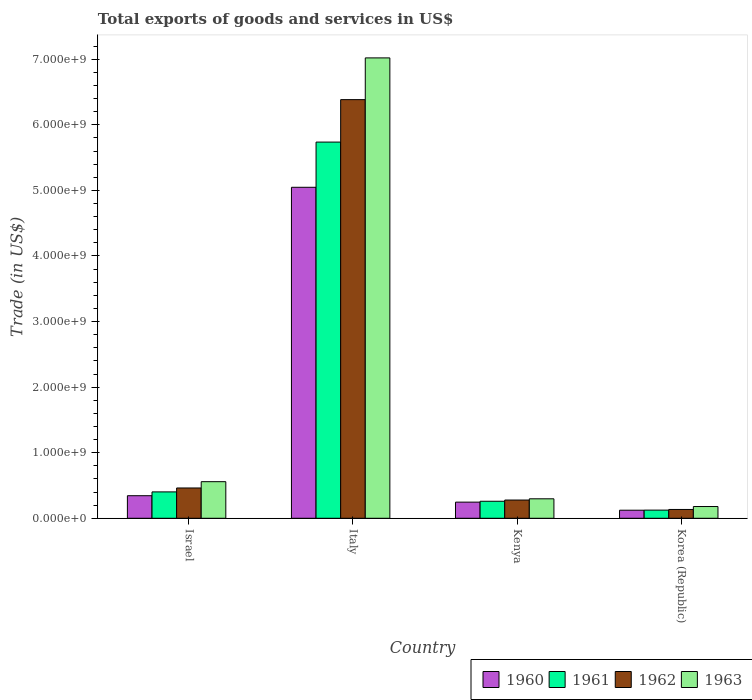Are the number of bars on each tick of the X-axis equal?
Your response must be concise. Yes. In how many cases, is the number of bars for a given country not equal to the number of legend labels?
Make the answer very short. 0. What is the total exports of goods and services in 1960 in Kenya?
Keep it short and to the point. 2.46e+08. Across all countries, what is the maximum total exports of goods and services in 1960?
Make the answer very short. 5.05e+09. Across all countries, what is the minimum total exports of goods and services in 1960?
Make the answer very short. 1.23e+08. In which country was the total exports of goods and services in 1960 maximum?
Offer a very short reply. Italy. What is the total total exports of goods and services in 1960 in the graph?
Offer a very short reply. 5.76e+09. What is the difference between the total exports of goods and services in 1960 in Israel and that in Korea (Republic)?
Your answer should be very brief. 2.21e+08. What is the difference between the total exports of goods and services in 1960 in Italy and the total exports of goods and services in 1962 in Korea (Republic)?
Offer a terse response. 4.91e+09. What is the average total exports of goods and services in 1962 per country?
Give a very brief answer. 1.81e+09. What is the difference between the total exports of goods and services of/in 1960 and total exports of goods and services of/in 1963 in Israel?
Give a very brief answer. -2.14e+08. In how many countries, is the total exports of goods and services in 1960 greater than 2400000000 US$?
Keep it short and to the point. 1. What is the ratio of the total exports of goods and services in 1962 in Israel to that in Kenya?
Your response must be concise. 1.66. Is the total exports of goods and services in 1961 in Italy less than that in Korea (Republic)?
Give a very brief answer. No. What is the difference between the highest and the second highest total exports of goods and services in 1961?
Ensure brevity in your answer.  1.43e+08. What is the difference between the highest and the lowest total exports of goods and services in 1961?
Keep it short and to the point. 5.61e+09. In how many countries, is the total exports of goods and services in 1963 greater than the average total exports of goods and services in 1963 taken over all countries?
Provide a short and direct response. 1. Is it the case that in every country, the sum of the total exports of goods and services in 1963 and total exports of goods and services in 1962 is greater than the sum of total exports of goods and services in 1960 and total exports of goods and services in 1961?
Keep it short and to the point. No. What does the 4th bar from the left in Korea (Republic) represents?
Your answer should be very brief. 1963. How many bars are there?
Your answer should be compact. 16. Are all the bars in the graph horizontal?
Offer a terse response. No. What is the difference between two consecutive major ticks on the Y-axis?
Ensure brevity in your answer.  1.00e+09. Does the graph contain any zero values?
Offer a very short reply. No. Does the graph contain grids?
Your answer should be very brief. No. How many legend labels are there?
Offer a very short reply. 4. What is the title of the graph?
Make the answer very short. Total exports of goods and services in US$. What is the label or title of the Y-axis?
Offer a terse response. Trade (in US$). What is the Trade (in US$) of 1960 in Israel?
Provide a succinct answer. 3.44e+08. What is the Trade (in US$) in 1961 in Israel?
Keep it short and to the point. 4.02e+08. What is the Trade (in US$) in 1962 in Israel?
Keep it short and to the point. 4.62e+08. What is the Trade (in US$) in 1963 in Israel?
Give a very brief answer. 5.58e+08. What is the Trade (in US$) of 1960 in Italy?
Provide a succinct answer. 5.05e+09. What is the Trade (in US$) of 1961 in Italy?
Provide a short and direct response. 5.74e+09. What is the Trade (in US$) of 1962 in Italy?
Ensure brevity in your answer.  6.38e+09. What is the Trade (in US$) of 1963 in Italy?
Offer a very short reply. 7.02e+09. What is the Trade (in US$) in 1960 in Kenya?
Make the answer very short. 2.46e+08. What is the Trade (in US$) in 1961 in Kenya?
Your answer should be compact. 2.59e+08. What is the Trade (in US$) in 1962 in Kenya?
Your answer should be compact. 2.78e+08. What is the Trade (in US$) in 1963 in Kenya?
Offer a terse response. 2.97e+08. What is the Trade (in US$) of 1960 in Korea (Republic)?
Make the answer very short. 1.23e+08. What is the Trade (in US$) of 1961 in Korea (Republic)?
Your answer should be compact. 1.24e+08. What is the Trade (in US$) in 1962 in Korea (Republic)?
Offer a terse response. 1.34e+08. What is the Trade (in US$) of 1963 in Korea (Republic)?
Your answer should be compact. 1.79e+08. Across all countries, what is the maximum Trade (in US$) of 1960?
Keep it short and to the point. 5.05e+09. Across all countries, what is the maximum Trade (in US$) of 1961?
Offer a very short reply. 5.74e+09. Across all countries, what is the maximum Trade (in US$) in 1962?
Offer a terse response. 6.38e+09. Across all countries, what is the maximum Trade (in US$) in 1963?
Your answer should be compact. 7.02e+09. Across all countries, what is the minimum Trade (in US$) of 1960?
Make the answer very short. 1.23e+08. Across all countries, what is the minimum Trade (in US$) of 1961?
Your answer should be compact. 1.24e+08. Across all countries, what is the minimum Trade (in US$) of 1962?
Offer a terse response. 1.34e+08. Across all countries, what is the minimum Trade (in US$) of 1963?
Your answer should be very brief. 1.79e+08. What is the total Trade (in US$) in 1960 in the graph?
Provide a succinct answer. 5.76e+09. What is the total Trade (in US$) in 1961 in the graph?
Keep it short and to the point. 6.52e+09. What is the total Trade (in US$) in 1962 in the graph?
Give a very brief answer. 7.26e+09. What is the total Trade (in US$) in 1963 in the graph?
Offer a very short reply. 8.05e+09. What is the difference between the Trade (in US$) in 1960 in Israel and that in Italy?
Your response must be concise. -4.70e+09. What is the difference between the Trade (in US$) in 1961 in Israel and that in Italy?
Keep it short and to the point. -5.33e+09. What is the difference between the Trade (in US$) in 1962 in Israel and that in Italy?
Offer a very short reply. -5.92e+09. What is the difference between the Trade (in US$) in 1963 in Israel and that in Italy?
Give a very brief answer. -6.46e+09. What is the difference between the Trade (in US$) of 1960 in Israel and that in Kenya?
Your response must be concise. 9.78e+07. What is the difference between the Trade (in US$) in 1961 in Israel and that in Kenya?
Offer a very short reply. 1.43e+08. What is the difference between the Trade (in US$) in 1962 in Israel and that in Kenya?
Your response must be concise. 1.84e+08. What is the difference between the Trade (in US$) in 1963 in Israel and that in Kenya?
Your answer should be compact. 2.61e+08. What is the difference between the Trade (in US$) in 1960 in Israel and that in Korea (Republic)?
Ensure brevity in your answer.  2.21e+08. What is the difference between the Trade (in US$) of 1961 in Israel and that in Korea (Republic)?
Your answer should be compact. 2.78e+08. What is the difference between the Trade (in US$) in 1962 in Israel and that in Korea (Republic)?
Provide a succinct answer. 3.28e+08. What is the difference between the Trade (in US$) of 1963 in Israel and that in Korea (Republic)?
Give a very brief answer. 3.79e+08. What is the difference between the Trade (in US$) in 1960 in Italy and that in Kenya?
Make the answer very short. 4.80e+09. What is the difference between the Trade (in US$) of 1961 in Italy and that in Kenya?
Provide a short and direct response. 5.48e+09. What is the difference between the Trade (in US$) of 1962 in Italy and that in Kenya?
Your answer should be very brief. 6.11e+09. What is the difference between the Trade (in US$) in 1963 in Italy and that in Kenya?
Make the answer very short. 6.72e+09. What is the difference between the Trade (in US$) in 1960 in Italy and that in Korea (Republic)?
Offer a very short reply. 4.92e+09. What is the difference between the Trade (in US$) in 1961 in Italy and that in Korea (Republic)?
Provide a short and direct response. 5.61e+09. What is the difference between the Trade (in US$) of 1962 in Italy and that in Korea (Republic)?
Provide a short and direct response. 6.25e+09. What is the difference between the Trade (in US$) in 1963 in Italy and that in Korea (Republic)?
Offer a terse response. 6.84e+09. What is the difference between the Trade (in US$) of 1960 in Kenya and that in Korea (Republic)?
Your response must be concise. 1.23e+08. What is the difference between the Trade (in US$) of 1961 in Kenya and that in Korea (Republic)?
Give a very brief answer. 1.35e+08. What is the difference between the Trade (in US$) of 1962 in Kenya and that in Korea (Republic)?
Offer a terse response. 1.44e+08. What is the difference between the Trade (in US$) of 1963 in Kenya and that in Korea (Republic)?
Offer a very short reply. 1.18e+08. What is the difference between the Trade (in US$) in 1960 in Israel and the Trade (in US$) in 1961 in Italy?
Your answer should be very brief. -5.39e+09. What is the difference between the Trade (in US$) of 1960 in Israel and the Trade (in US$) of 1962 in Italy?
Give a very brief answer. -6.04e+09. What is the difference between the Trade (in US$) of 1960 in Israel and the Trade (in US$) of 1963 in Italy?
Provide a succinct answer. -6.68e+09. What is the difference between the Trade (in US$) of 1961 in Israel and the Trade (in US$) of 1962 in Italy?
Your answer should be compact. -5.98e+09. What is the difference between the Trade (in US$) of 1961 in Israel and the Trade (in US$) of 1963 in Italy?
Your answer should be compact. -6.62e+09. What is the difference between the Trade (in US$) in 1962 in Israel and the Trade (in US$) in 1963 in Italy?
Offer a very short reply. -6.56e+09. What is the difference between the Trade (in US$) in 1960 in Israel and the Trade (in US$) in 1961 in Kenya?
Give a very brief answer. 8.45e+07. What is the difference between the Trade (in US$) in 1960 in Israel and the Trade (in US$) in 1962 in Kenya?
Your answer should be compact. 6.58e+07. What is the difference between the Trade (in US$) of 1960 in Israel and the Trade (in US$) of 1963 in Kenya?
Your answer should be very brief. 4.71e+07. What is the difference between the Trade (in US$) of 1961 in Israel and the Trade (in US$) of 1962 in Kenya?
Give a very brief answer. 1.24e+08. What is the difference between the Trade (in US$) in 1961 in Israel and the Trade (in US$) in 1963 in Kenya?
Provide a succinct answer. 1.05e+08. What is the difference between the Trade (in US$) of 1962 in Israel and the Trade (in US$) of 1963 in Kenya?
Your response must be concise. 1.65e+08. What is the difference between the Trade (in US$) in 1960 in Israel and the Trade (in US$) in 1961 in Korea (Republic)?
Provide a succinct answer. 2.20e+08. What is the difference between the Trade (in US$) of 1960 in Israel and the Trade (in US$) of 1962 in Korea (Republic)?
Your answer should be very brief. 2.10e+08. What is the difference between the Trade (in US$) in 1960 in Israel and the Trade (in US$) in 1963 in Korea (Republic)?
Give a very brief answer. 1.65e+08. What is the difference between the Trade (in US$) of 1961 in Israel and the Trade (in US$) of 1962 in Korea (Republic)?
Your answer should be compact. 2.68e+08. What is the difference between the Trade (in US$) of 1961 in Israel and the Trade (in US$) of 1963 in Korea (Republic)?
Give a very brief answer. 2.23e+08. What is the difference between the Trade (in US$) of 1962 in Israel and the Trade (in US$) of 1963 in Korea (Republic)?
Make the answer very short. 2.83e+08. What is the difference between the Trade (in US$) of 1960 in Italy and the Trade (in US$) of 1961 in Kenya?
Provide a succinct answer. 4.79e+09. What is the difference between the Trade (in US$) in 1960 in Italy and the Trade (in US$) in 1962 in Kenya?
Keep it short and to the point. 4.77e+09. What is the difference between the Trade (in US$) in 1960 in Italy and the Trade (in US$) in 1963 in Kenya?
Offer a terse response. 4.75e+09. What is the difference between the Trade (in US$) of 1961 in Italy and the Trade (in US$) of 1962 in Kenya?
Provide a succinct answer. 5.46e+09. What is the difference between the Trade (in US$) in 1961 in Italy and the Trade (in US$) in 1963 in Kenya?
Keep it short and to the point. 5.44e+09. What is the difference between the Trade (in US$) in 1962 in Italy and the Trade (in US$) in 1963 in Kenya?
Your answer should be compact. 6.09e+09. What is the difference between the Trade (in US$) in 1960 in Italy and the Trade (in US$) in 1961 in Korea (Republic)?
Your response must be concise. 4.92e+09. What is the difference between the Trade (in US$) in 1960 in Italy and the Trade (in US$) in 1962 in Korea (Republic)?
Make the answer very short. 4.91e+09. What is the difference between the Trade (in US$) in 1960 in Italy and the Trade (in US$) in 1963 in Korea (Republic)?
Provide a short and direct response. 4.87e+09. What is the difference between the Trade (in US$) of 1961 in Italy and the Trade (in US$) of 1962 in Korea (Republic)?
Your response must be concise. 5.60e+09. What is the difference between the Trade (in US$) of 1961 in Italy and the Trade (in US$) of 1963 in Korea (Republic)?
Make the answer very short. 5.56e+09. What is the difference between the Trade (in US$) of 1962 in Italy and the Trade (in US$) of 1963 in Korea (Republic)?
Keep it short and to the point. 6.20e+09. What is the difference between the Trade (in US$) of 1960 in Kenya and the Trade (in US$) of 1961 in Korea (Republic)?
Give a very brief answer. 1.22e+08. What is the difference between the Trade (in US$) of 1960 in Kenya and the Trade (in US$) of 1962 in Korea (Republic)?
Ensure brevity in your answer.  1.12e+08. What is the difference between the Trade (in US$) in 1960 in Kenya and the Trade (in US$) in 1963 in Korea (Republic)?
Your answer should be very brief. 6.70e+07. What is the difference between the Trade (in US$) in 1961 in Kenya and the Trade (in US$) in 1962 in Korea (Republic)?
Your answer should be very brief. 1.25e+08. What is the difference between the Trade (in US$) of 1961 in Kenya and the Trade (in US$) of 1963 in Korea (Republic)?
Offer a very short reply. 8.04e+07. What is the difference between the Trade (in US$) in 1962 in Kenya and the Trade (in US$) in 1963 in Korea (Republic)?
Your answer should be very brief. 9.91e+07. What is the average Trade (in US$) in 1960 per country?
Offer a terse response. 1.44e+09. What is the average Trade (in US$) in 1961 per country?
Make the answer very short. 1.63e+09. What is the average Trade (in US$) in 1962 per country?
Your response must be concise. 1.81e+09. What is the average Trade (in US$) of 1963 per country?
Your answer should be compact. 2.01e+09. What is the difference between the Trade (in US$) of 1960 and Trade (in US$) of 1961 in Israel?
Your answer should be very brief. -5.83e+07. What is the difference between the Trade (in US$) of 1960 and Trade (in US$) of 1962 in Israel?
Give a very brief answer. -1.18e+08. What is the difference between the Trade (in US$) in 1960 and Trade (in US$) in 1963 in Israel?
Ensure brevity in your answer.  -2.14e+08. What is the difference between the Trade (in US$) of 1961 and Trade (in US$) of 1962 in Israel?
Give a very brief answer. -5.98e+07. What is the difference between the Trade (in US$) in 1961 and Trade (in US$) in 1963 in Israel?
Your response must be concise. -1.56e+08. What is the difference between the Trade (in US$) in 1962 and Trade (in US$) in 1963 in Israel?
Give a very brief answer. -9.59e+07. What is the difference between the Trade (in US$) of 1960 and Trade (in US$) of 1961 in Italy?
Your response must be concise. -6.89e+08. What is the difference between the Trade (in US$) in 1960 and Trade (in US$) in 1962 in Italy?
Give a very brief answer. -1.34e+09. What is the difference between the Trade (in US$) in 1960 and Trade (in US$) in 1963 in Italy?
Offer a terse response. -1.97e+09. What is the difference between the Trade (in US$) of 1961 and Trade (in US$) of 1962 in Italy?
Keep it short and to the point. -6.47e+08. What is the difference between the Trade (in US$) in 1961 and Trade (in US$) in 1963 in Italy?
Ensure brevity in your answer.  -1.28e+09. What is the difference between the Trade (in US$) of 1962 and Trade (in US$) of 1963 in Italy?
Make the answer very short. -6.37e+08. What is the difference between the Trade (in US$) in 1960 and Trade (in US$) in 1961 in Kenya?
Provide a succinct answer. -1.34e+07. What is the difference between the Trade (in US$) of 1960 and Trade (in US$) of 1962 in Kenya?
Give a very brief answer. -3.21e+07. What is the difference between the Trade (in US$) in 1960 and Trade (in US$) in 1963 in Kenya?
Offer a very short reply. -5.08e+07. What is the difference between the Trade (in US$) of 1961 and Trade (in US$) of 1962 in Kenya?
Offer a terse response. -1.87e+07. What is the difference between the Trade (in US$) in 1961 and Trade (in US$) in 1963 in Kenya?
Offer a very short reply. -3.74e+07. What is the difference between the Trade (in US$) of 1962 and Trade (in US$) of 1963 in Kenya?
Offer a terse response. -1.87e+07. What is the difference between the Trade (in US$) in 1960 and Trade (in US$) in 1961 in Korea (Republic)?
Offer a very short reply. -1.44e+06. What is the difference between the Trade (in US$) in 1960 and Trade (in US$) in 1962 in Korea (Republic)?
Your answer should be very brief. -1.14e+07. What is the difference between the Trade (in US$) of 1960 and Trade (in US$) of 1963 in Korea (Republic)?
Offer a very short reply. -5.61e+07. What is the difference between the Trade (in US$) of 1961 and Trade (in US$) of 1962 in Korea (Republic)?
Give a very brief answer. -9.94e+06. What is the difference between the Trade (in US$) of 1961 and Trade (in US$) of 1963 in Korea (Republic)?
Give a very brief answer. -5.47e+07. What is the difference between the Trade (in US$) in 1962 and Trade (in US$) in 1963 in Korea (Republic)?
Provide a succinct answer. -4.48e+07. What is the ratio of the Trade (in US$) in 1960 in Israel to that in Italy?
Ensure brevity in your answer.  0.07. What is the ratio of the Trade (in US$) of 1961 in Israel to that in Italy?
Offer a terse response. 0.07. What is the ratio of the Trade (in US$) of 1962 in Israel to that in Italy?
Offer a terse response. 0.07. What is the ratio of the Trade (in US$) of 1963 in Israel to that in Italy?
Provide a succinct answer. 0.08. What is the ratio of the Trade (in US$) in 1960 in Israel to that in Kenya?
Make the answer very short. 1.4. What is the ratio of the Trade (in US$) of 1961 in Israel to that in Kenya?
Provide a succinct answer. 1.55. What is the ratio of the Trade (in US$) in 1962 in Israel to that in Kenya?
Give a very brief answer. 1.66. What is the ratio of the Trade (in US$) in 1963 in Israel to that in Kenya?
Your response must be concise. 1.88. What is the ratio of the Trade (in US$) in 1960 in Israel to that in Korea (Republic)?
Ensure brevity in your answer.  2.8. What is the ratio of the Trade (in US$) of 1961 in Israel to that in Korea (Republic)?
Give a very brief answer. 3.23. What is the ratio of the Trade (in US$) in 1962 in Israel to that in Korea (Republic)?
Your answer should be compact. 3.44. What is the ratio of the Trade (in US$) in 1963 in Israel to that in Korea (Republic)?
Give a very brief answer. 3.12. What is the ratio of the Trade (in US$) of 1960 in Italy to that in Kenya?
Your answer should be compact. 20.51. What is the ratio of the Trade (in US$) in 1961 in Italy to that in Kenya?
Your answer should be compact. 22.11. What is the ratio of the Trade (in US$) of 1962 in Italy to that in Kenya?
Provide a succinct answer. 22.95. What is the ratio of the Trade (in US$) in 1963 in Italy to that in Kenya?
Your response must be concise. 23.65. What is the ratio of the Trade (in US$) of 1960 in Italy to that in Korea (Republic)?
Ensure brevity in your answer.  41.06. What is the ratio of the Trade (in US$) of 1961 in Italy to that in Korea (Republic)?
Make the answer very short. 46.13. What is the ratio of the Trade (in US$) in 1962 in Italy to that in Korea (Republic)?
Make the answer very short. 47.54. What is the ratio of the Trade (in US$) in 1963 in Italy to that in Korea (Republic)?
Keep it short and to the point. 39.21. What is the ratio of the Trade (in US$) of 1960 in Kenya to that in Korea (Republic)?
Your answer should be compact. 2. What is the ratio of the Trade (in US$) of 1961 in Kenya to that in Korea (Republic)?
Your answer should be very brief. 2.09. What is the ratio of the Trade (in US$) in 1962 in Kenya to that in Korea (Republic)?
Provide a short and direct response. 2.07. What is the ratio of the Trade (in US$) in 1963 in Kenya to that in Korea (Republic)?
Provide a short and direct response. 1.66. What is the difference between the highest and the second highest Trade (in US$) in 1960?
Your answer should be compact. 4.70e+09. What is the difference between the highest and the second highest Trade (in US$) of 1961?
Your answer should be very brief. 5.33e+09. What is the difference between the highest and the second highest Trade (in US$) in 1962?
Provide a short and direct response. 5.92e+09. What is the difference between the highest and the second highest Trade (in US$) in 1963?
Provide a short and direct response. 6.46e+09. What is the difference between the highest and the lowest Trade (in US$) of 1960?
Provide a short and direct response. 4.92e+09. What is the difference between the highest and the lowest Trade (in US$) of 1961?
Give a very brief answer. 5.61e+09. What is the difference between the highest and the lowest Trade (in US$) in 1962?
Provide a short and direct response. 6.25e+09. What is the difference between the highest and the lowest Trade (in US$) in 1963?
Offer a terse response. 6.84e+09. 